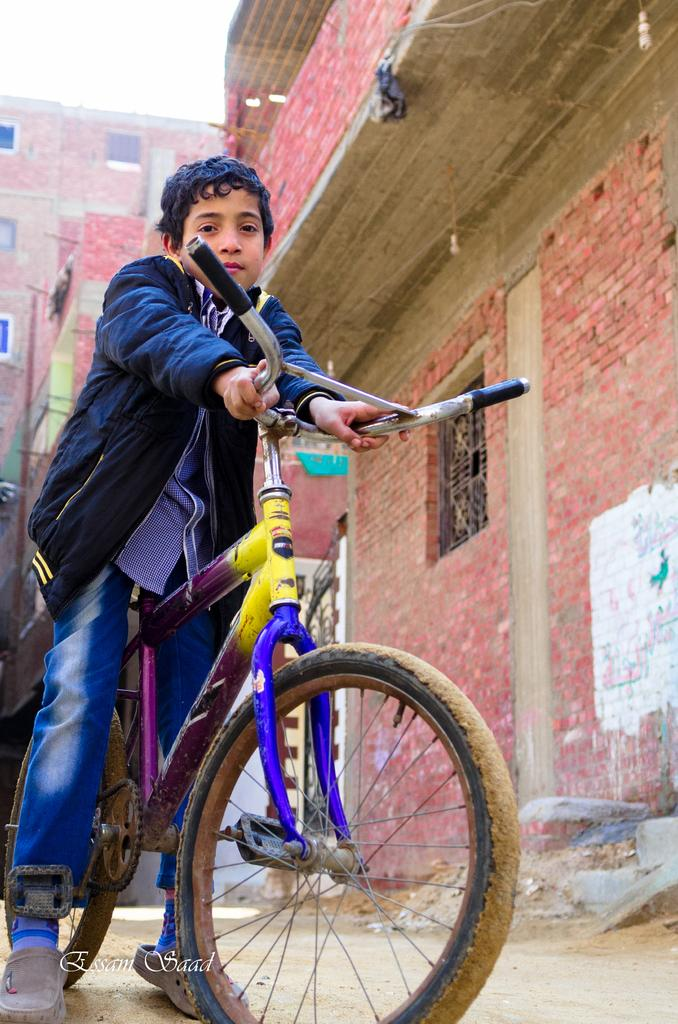Who is the main subject in the image? There is a boy in the image. What is the boy wearing? The boy is wearing a jacket. What is the boy holding in the image? The boy is holding a cycle with his hand. What can be seen in the background of the image? There is a building with bricks and windows in the background of the image. What type of power does the manager have over the screw in the image? There is no manager or screw present in the image. 